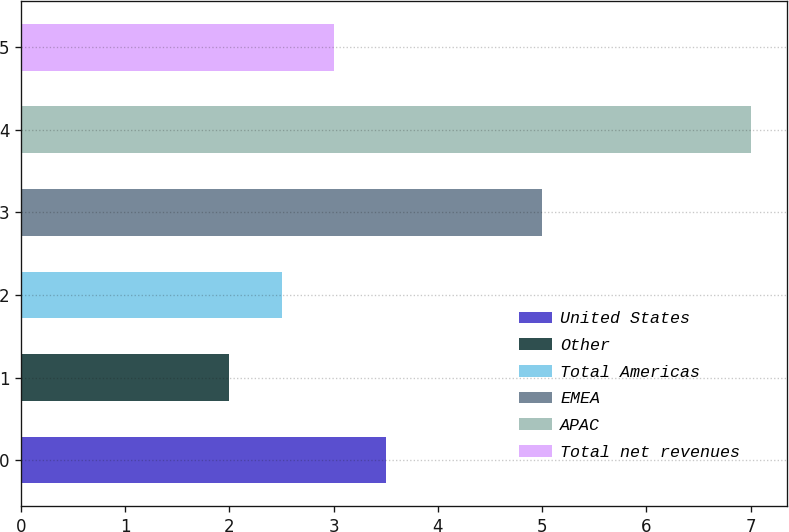Convert chart to OTSL. <chart><loc_0><loc_0><loc_500><loc_500><bar_chart><fcel>United States<fcel>Other<fcel>Total Americas<fcel>EMEA<fcel>APAC<fcel>Total net revenues<nl><fcel>3.5<fcel>2<fcel>2.5<fcel>5<fcel>7<fcel>3<nl></chart> 